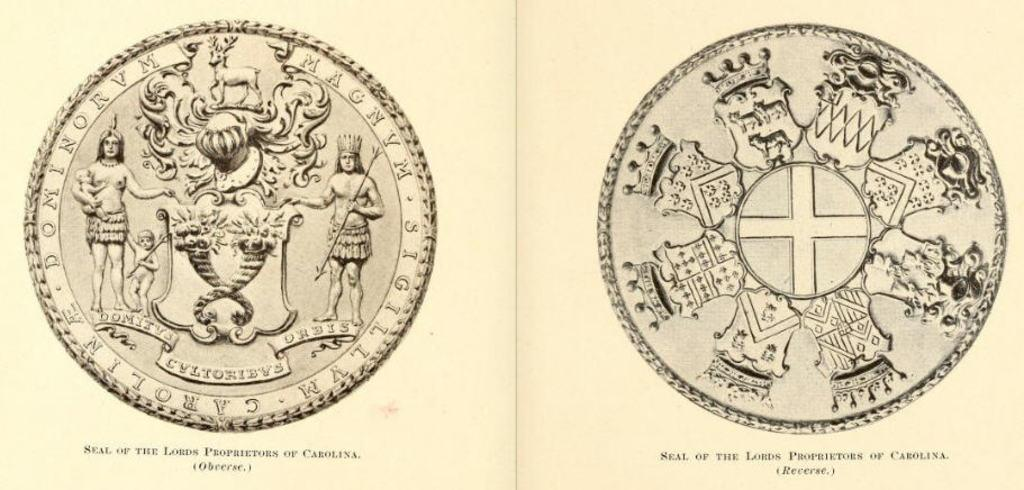Provide a one-sentence caption for the provided image. two coins with one having the seal of the lords proprietors. 